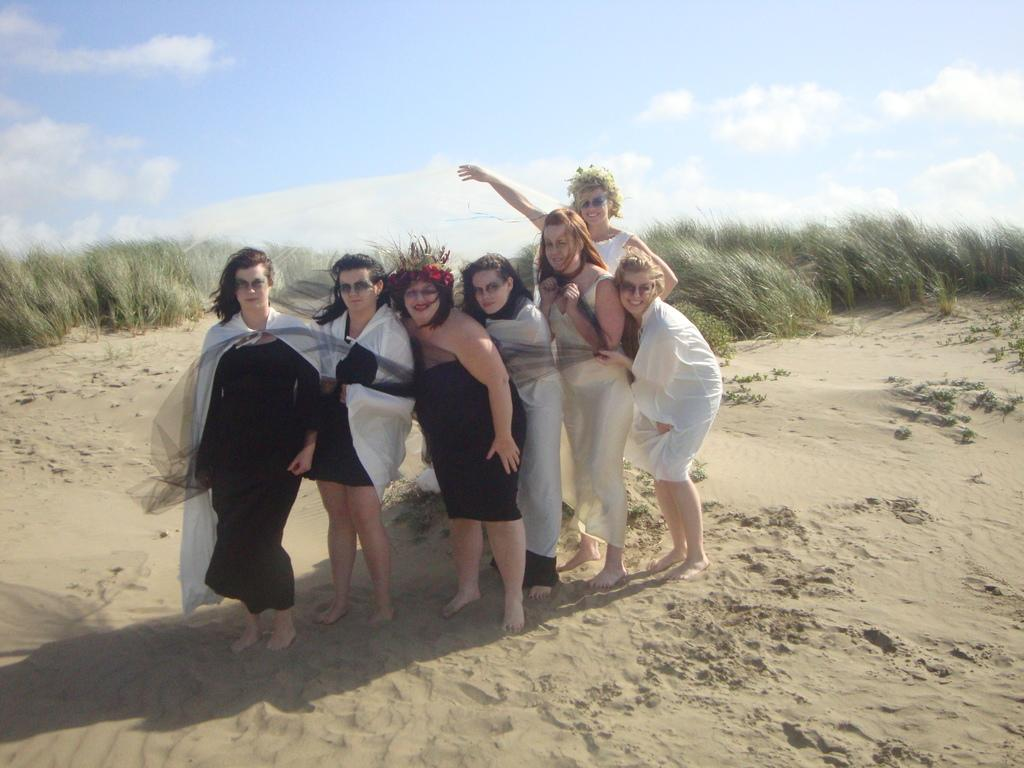How many people are present in the image? There are seven people in the image. What are the people doing in the image? The people are standing in the image. Which direction are the people facing? The people are facing straight in the image. What can be seen in the background of the image? There is grass and the sky visible in the background of the image. What type of wire is being used to hold the sofa in the image? There is no wire or sofa present in the image. How far away is the distance between the people in the image? The concept of "distance" between the people is not mentioned in the provided facts, so it cannot be determined from the image. 